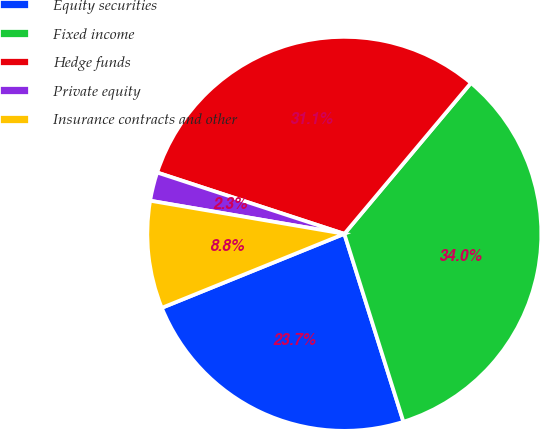Convert chart to OTSL. <chart><loc_0><loc_0><loc_500><loc_500><pie_chart><fcel>Equity securities<fcel>Fixed income<fcel>Hedge funds<fcel>Private equity<fcel>Insurance contracts and other<nl><fcel>23.72%<fcel>34.04%<fcel>31.07%<fcel>2.35%<fcel>8.82%<nl></chart> 